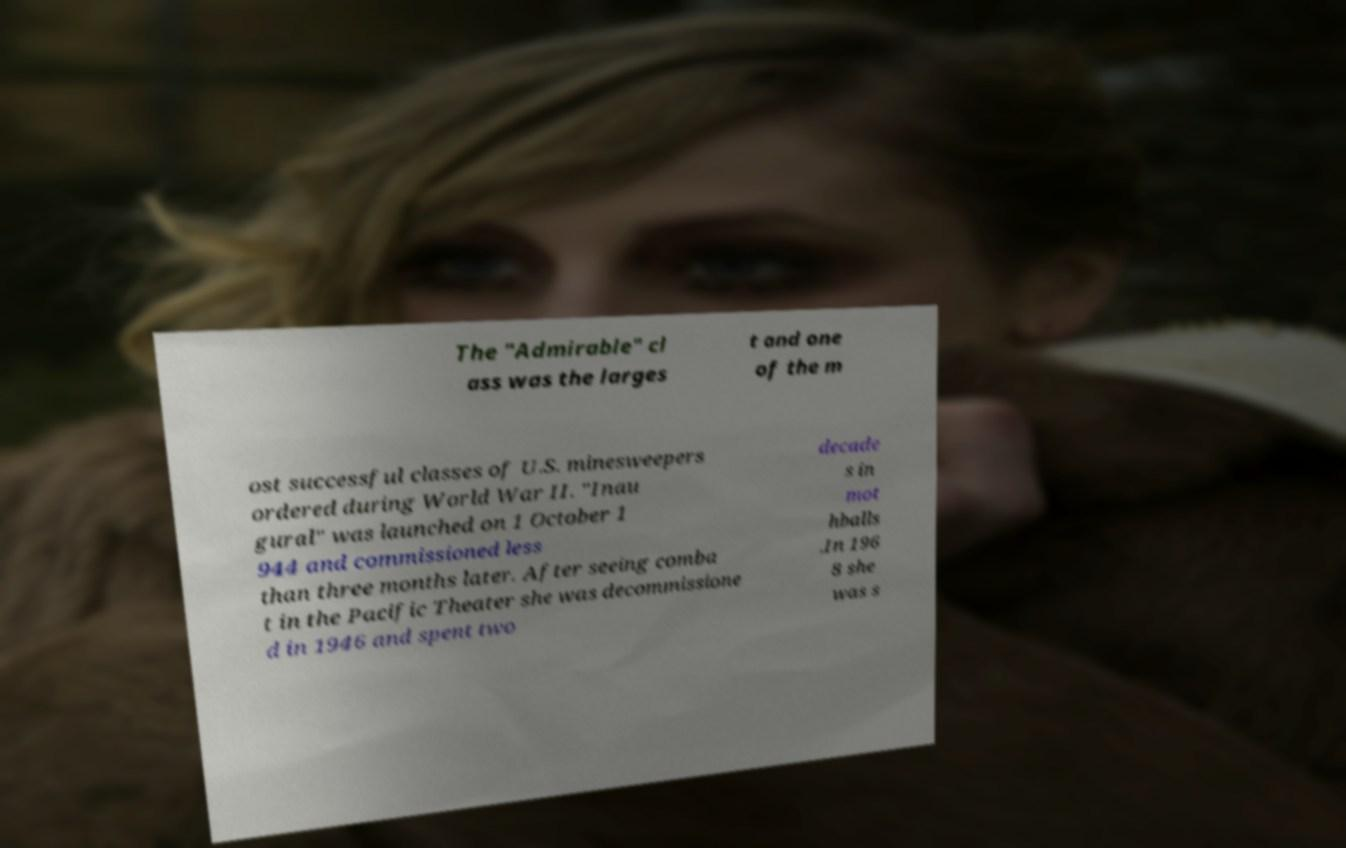Please identify and transcribe the text found in this image. The "Admirable" cl ass was the larges t and one of the m ost successful classes of U.S. minesweepers ordered during World War II. "Inau gural" was launched on 1 October 1 944 and commissioned less than three months later. After seeing comba t in the Pacific Theater she was decommissione d in 1946 and spent two decade s in mot hballs .In 196 8 she was s 